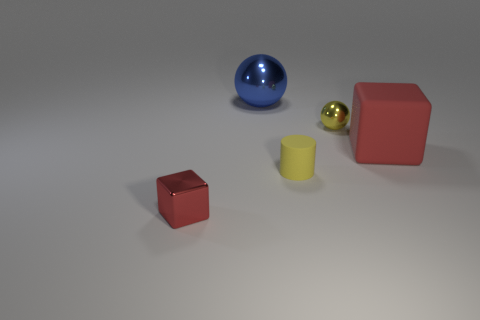There is a red matte block; is it the same size as the ball that is to the left of the tiny rubber cylinder?
Make the answer very short. Yes. There is a shiny thing that is both on the left side of the small yellow metal thing and in front of the blue object; what shape is it?
Offer a terse response. Cube. What number of big objects are either shiny things or red objects?
Your answer should be very brief. 2. Is the number of tiny red blocks that are right of the cylinder the same as the number of tiny things in front of the yellow shiny ball?
Your answer should be very brief. No. How many other objects are there of the same color as the tiny ball?
Make the answer very short. 1. Are there the same number of red matte cubes to the right of the yellow matte cylinder and tiny yellow rubber cylinders?
Provide a succinct answer. Yes. Does the red metal block have the same size as the yellow metallic sphere?
Your answer should be compact. Yes. What is the thing that is in front of the yellow shiny ball and behind the small yellow cylinder made of?
Ensure brevity in your answer.  Rubber. How many other red things have the same shape as the big red object?
Offer a very short reply. 1. There is a thing on the left side of the big metal ball; what is it made of?
Make the answer very short. Metal. 